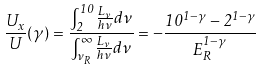Convert formula to latex. <formula><loc_0><loc_0><loc_500><loc_500>\frac { U _ { x } } { U } ( \gamma ) = \frac { \int _ { 2 } ^ { 1 0 } \frac { L _ { \nu } } { h \nu } d \nu } { \int _ { \nu _ { R } } ^ { \infty } \frac { L _ { \nu } } { h \nu } d \nu } = - \frac { 1 0 ^ { 1 - \gamma } - 2 ^ { 1 - \gamma } } { E _ { R } ^ { 1 - \gamma } }</formula> 